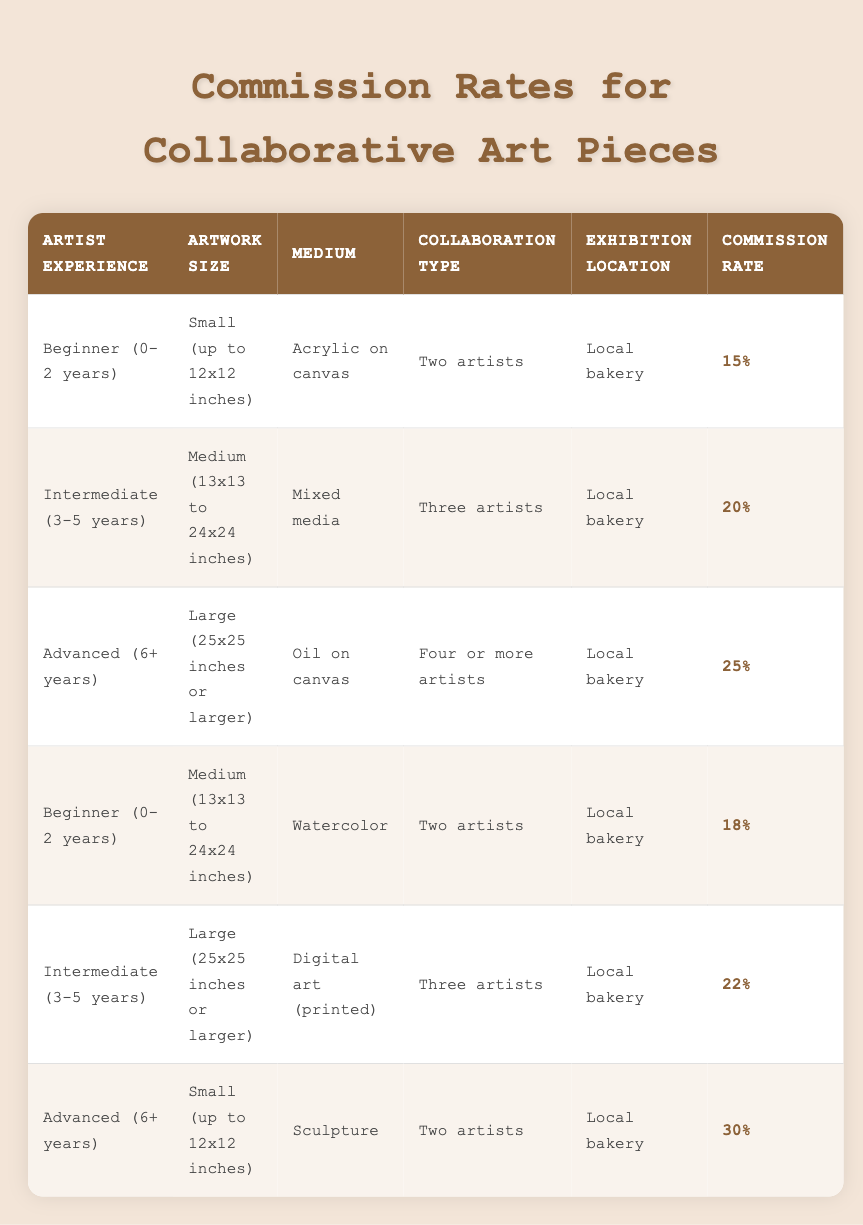What is the commission rate for an artwork created by two beginner artists? According to the table, the commission rate for Beginner (0-2 years) artists collaborating on a small artwork is 15%.
Answer: 15% What is the commission rate if three intermediate artists collaborate on a medium artwork? The table lists that for Intermediate (3-5 years) artists collaborating on a medium artwork, the commission rate is 20%.
Answer: 20% Is the commission rate higher for advanced artists compared to beginner artists for large artworks? Yes, the commission rate for Advanced artists (25% for large artworks) is higher than that for Beginner artists (18% for medium artworks).
Answer: Yes If an advanced artist collaborates with three other intermediate artists on a large artwork, what will be the commission rate? The commission rates for an advanced artist on large artwork is 25%, but if it’s a collaboration with an intermediate and follows the three artist rule, the same rate applies, so it remains 25%.
Answer: 25% What is the difference in commission rates between small artworks by advanced artists and medium artworks by beginners? For small artworks by advanced artists, the commission rate is 30%, and for medium artworks by beginner artists, it is 18%. The difference is 30% - 18% = 12%.
Answer: 12% What is the average commission rate for artworks done by beginner artists? There are two entries for beginner artists: 15% for a small artwork and 18% for a medium artwork. The average commission is (15% + 18%) / 2 = 16.5%.
Answer: 16.5% Can a beginner artist collaborate with more than two artists without changing the commission rate? No, the table specifies that for beginner artists, the collaboration must be with two artists, meaning exceeding this number changes the category and commission.
Answer: No What is the highest commission rate listed in the table? The highest commission rate in the table is 30%, associated with advanced artists creating small sculptures alongside another artist.
Answer: 30% Is it true that the commission rates for artworks increase with the number of collaborating artists? No, the commission rate does not follow a linear increase with the number of collaborating artists as indicated by the different rates attributed to each artist's experience despite collaboration size.
Answer: No 